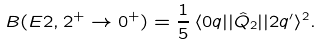<formula> <loc_0><loc_0><loc_500><loc_500>B ( E 2 , 2 ^ { + } \to 0 ^ { + } ) = \frac { 1 } { 5 } \, \langle 0 q | | \hat { Q } _ { 2 } | | 2 q ^ { \prime } \rangle ^ { 2 } .</formula> 